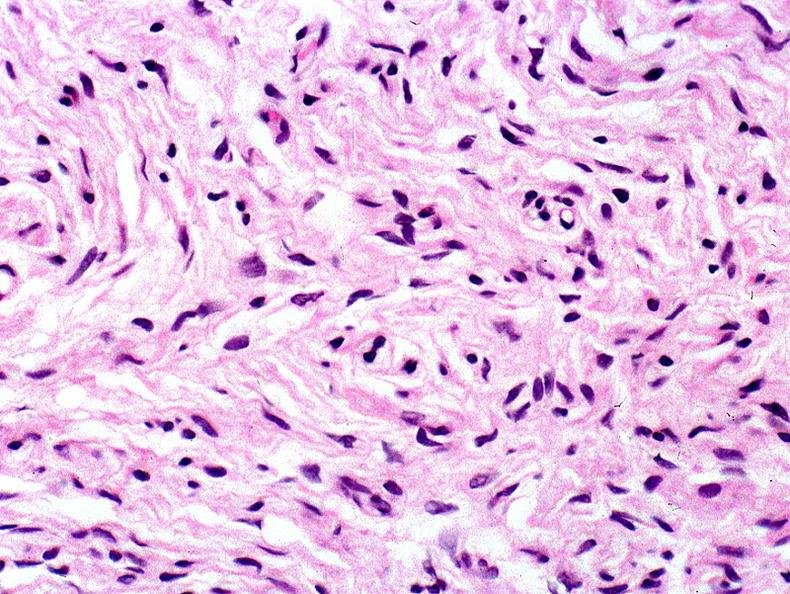where is this?
Answer the question using a single word or phrase. Skin 